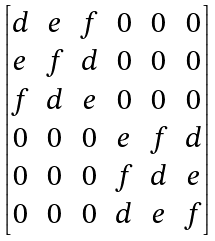<formula> <loc_0><loc_0><loc_500><loc_500>\begin{bmatrix} d & e & f & 0 & 0 & 0 \\ e & f & d & 0 & 0 & 0 \\ f & d & e & 0 & 0 & 0 \\ 0 & 0 & 0 & e & f & d \\ 0 & 0 & 0 & f & d & e \\ 0 & 0 & 0 & d & e & f \end{bmatrix}</formula> 